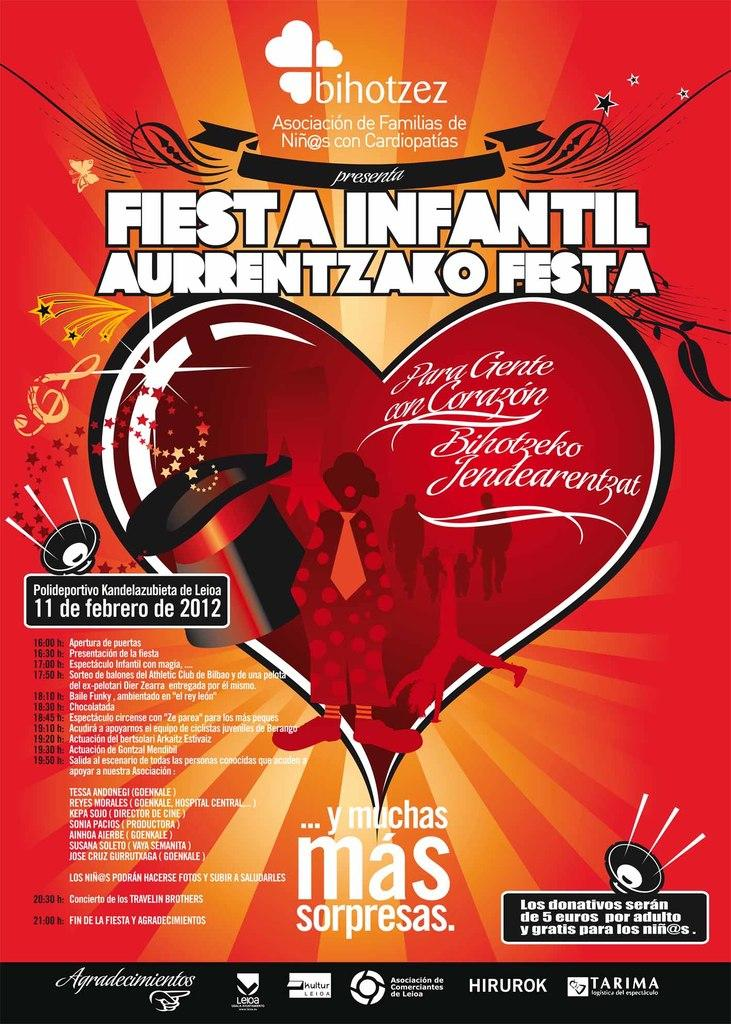<image>
Create a compact narrative representing the image presented. Poster for Fiesta Infantil Aurrentizako Festa in 2012. 